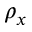Convert formula to latex. <formula><loc_0><loc_0><loc_500><loc_500>\rho _ { x }</formula> 